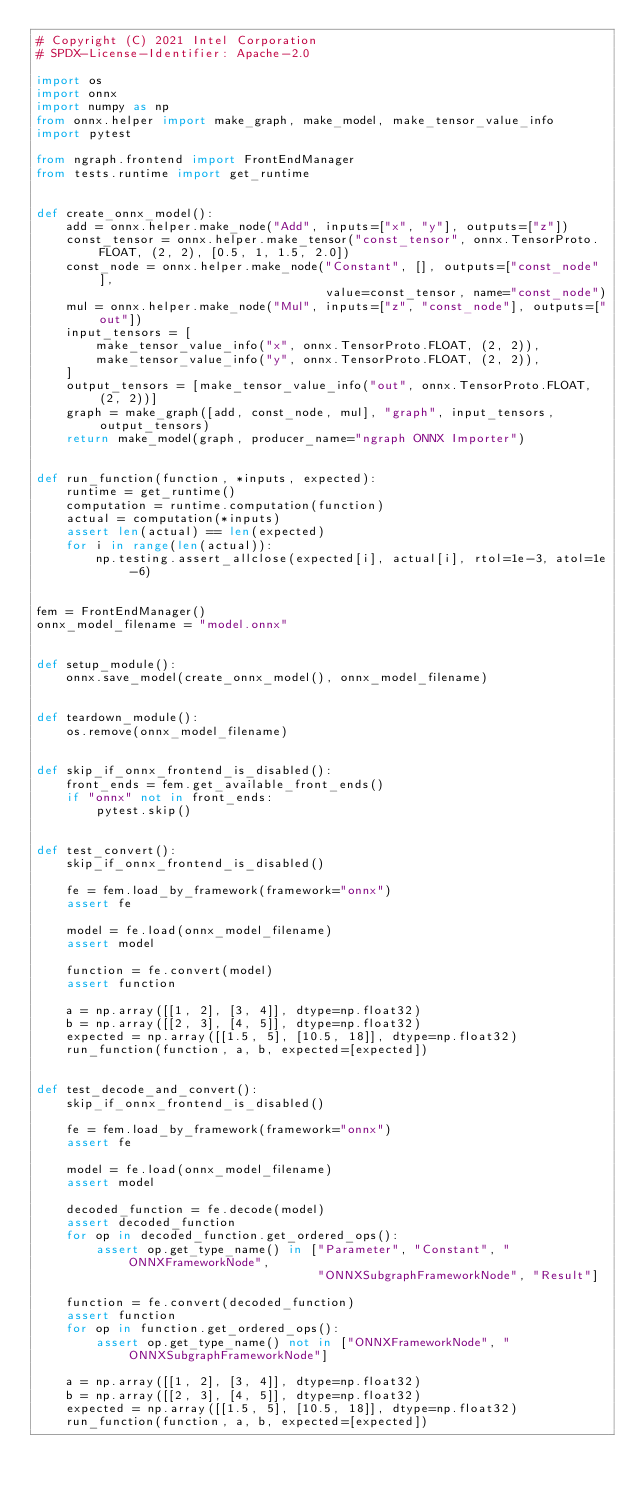Convert code to text. <code><loc_0><loc_0><loc_500><loc_500><_Python_># Copyright (C) 2021 Intel Corporation
# SPDX-License-Identifier: Apache-2.0

import os
import onnx
import numpy as np
from onnx.helper import make_graph, make_model, make_tensor_value_info
import pytest

from ngraph.frontend import FrontEndManager
from tests.runtime import get_runtime


def create_onnx_model():
    add = onnx.helper.make_node("Add", inputs=["x", "y"], outputs=["z"])
    const_tensor = onnx.helper.make_tensor("const_tensor", onnx.TensorProto.FLOAT, (2, 2), [0.5, 1, 1.5, 2.0])
    const_node = onnx.helper.make_node("Constant", [], outputs=["const_node"],
                                       value=const_tensor, name="const_node")
    mul = onnx.helper.make_node("Mul", inputs=["z", "const_node"], outputs=["out"])
    input_tensors = [
        make_tensor_value_info("x", onnx.TensorProto.FLOAT, (2, 2)),
        make_tensor_value_info("y", onnx.TensorProto.FLOAT, (2, 2)),
    ]
    output_tensors = [make_tensor_value_info("out", onnx.TensorProto.FLOAT, (2, 2))]
    graph = make_graph([add, const_node, mul], "graph", input_tensors, output_tensors)
    return make_model(graph, producer_name="ngraph ONNX Importer")


def run_function(function, *inputs, expected):
    runtime = get_runtime()
    computation = runtime.computation(function)
    actual = computation(*inputs)
    assert len(actual) == len(expected)
    for i in range(len(actual)):
        np.testing.assert_allclose(expected[i], actual[i], rtol=1e-3, atol=1e-6)


fem = FrontEndManager()
onnx_model_filename = "model.onnx"


def setup_module():
    onnx.save_model(create_onnx_model(), onnx_model_filename)


def teardown_module():
    os.remove(onnx_model_filename)


def skip_if_onnx_frontend_is_disabled():
    front_ends = fem.get_available_front_ends()
    if "onnx" not in front_ends:
        pytest.skip()


def test_convert():
    skip_if_onnx_frontend_is_disabled()

    fe = fem.load_by_framework(framework="onnx")
    assert fe

    model = fe.load(onnx_model_filename)
    assert model

    function = fe.convert(model)
    assert function

    a = np.array([[1, 2], [3, 4]], dtype=np.float32)
    b = np.array([[2, 3], [4, 5]], dtype=np.float32)
    expected = np.array([[1.5, 5], [10.5, 18]], dtype=np.float32)
    run_function(function, a, b, expected=[expected])


def test_decode_and_convert():
    skip_if_onnx_frontend_is_disabled()

    fe = fem.load_by_framework(framework="onnx")
    assert fe

    model = fe.load(onnx_model_filename)
    assert model

    decoded_function = fe.decode(model)
    assert decoded_function
    for op in decoded_function.get_ordered_ops():
        assert op.get_type_name() in ["Parameter", "Constant", "ONNXFrameworkNode",
                                      "ONNXSubgraphFrameworkNode", "Result"]

    function = fe.convert(decoded_function)
    assert function
    for op in function.get_ordered_ops():
        assert op.get_type_name() not in ["ONNXFrameworkNode", "ONNXSubgraphFrameworkNode"]

    a = np.array([[1, 2], [3, 4]], dtype=np.float32)
    b = np.array([[2, 3], [4, 5]], dtype=np.float32)
    expected = np.array([[1.5, 5], [10.5, 18]], dtype=np.float32)
    run_function(function, a, b, expected=[expected])
</code> 